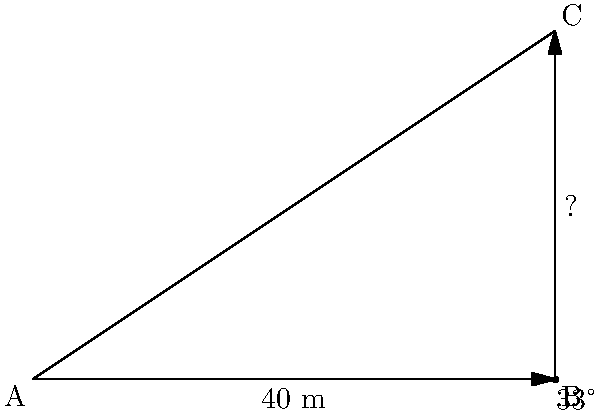A church spire forms a right-angled triangle with the ground. From a point 40 meters away from the base of the spire, the angle of elevation to the top of the spire is measured to be 33°. Calculate the height of the church spire to the nearest meter. Let's approach this step-by-step:

1) We can see that this forms a right-angled triangle, where:
   - The adjacent side is the distance from the observer to the base (40 m)
   - The opposite side is the height of the spire (what we're looking for)
   - The angle of elevation is 33°

2) In a right-angled triangle, we can use the tangent function to find the ratio of the opposite side to the adjacent side:

   $$\tan(\theta) = \frac{\text{opposite}}{\text{adjacent}}$$

3) Plugging in our known values:

   $$\tan(33°) = \frac{\text{height}}{40}$$

4) To solve for the height, we multiply both sides by 40:

   $$40 \times \tan(33°) = \text{height}$$

5) Now we can calculate:
   
   $$\text{height} = 40 \times \tan(33°) \approx 40 \times 0.6494 \approx 25.976$$

6) Rounding to the nearest meter:

   $$\text{height} \approx 26 \text{ meters}$$
Answer: 26 meters 